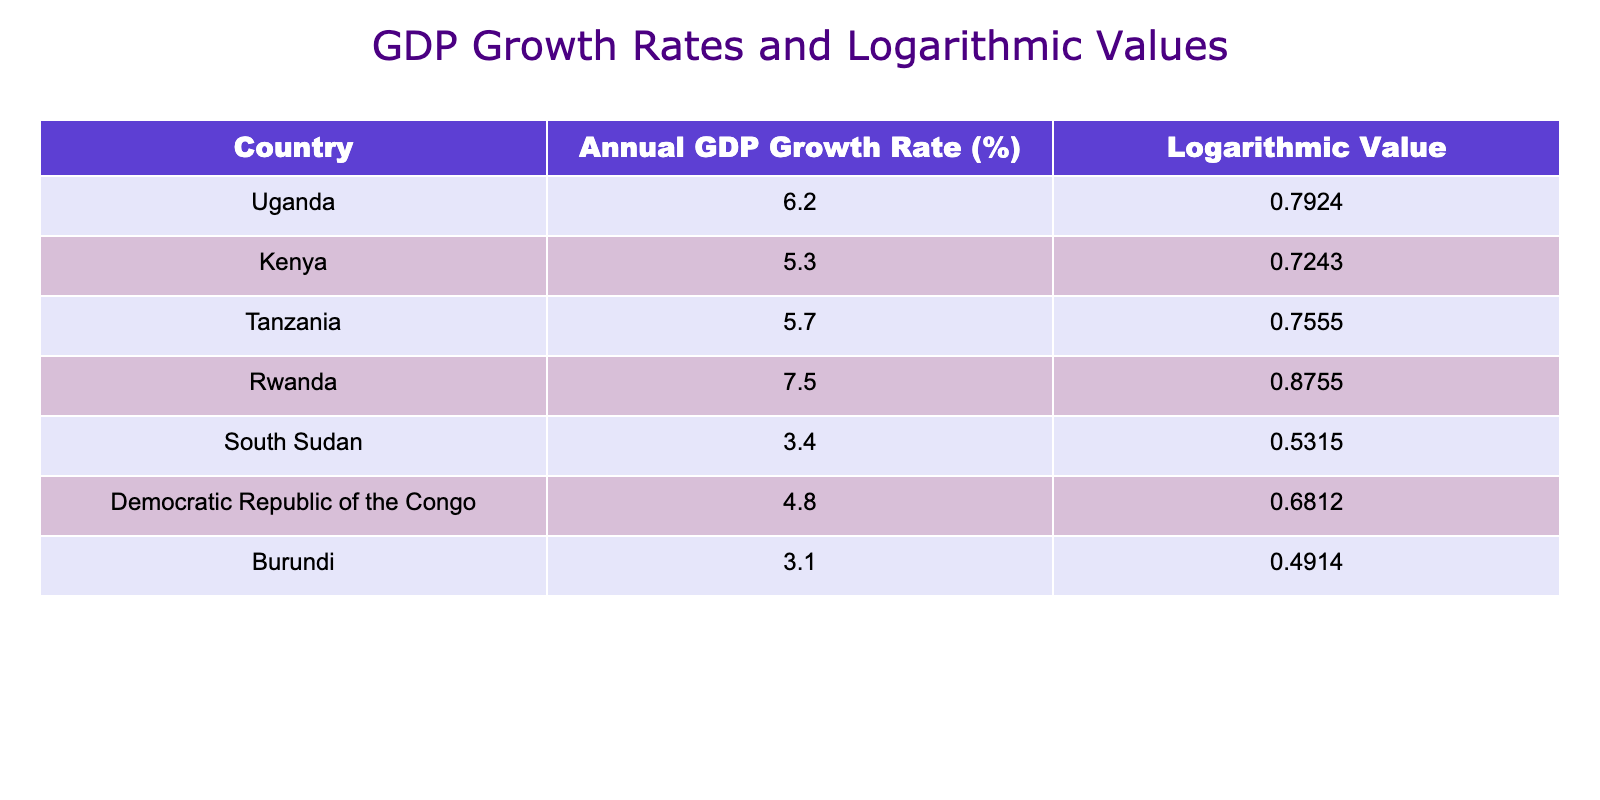What is the annual GDP growth rate of Uganda? Referring to the table, the annual GDP growth rate for Uganda is directly listed under that country.
Answer: 6.2% Which neighboring country has the highest annual GDP growth rate? By comparing the growth rates of the listed neighboring countries, Rwanda has the highest rate at 7.5%.
Answer: Rwanda What is the difference in annual GDP growth rate between Uganda and Kenya? The growth rate of Uganda is 6.2% and that of Kenya is 5.3%. The difference is calculated as 6.2 - 5.3 = 0.9%.
Answer: 0.9% What is the average annual GDP growth rate of all the countries listed? To find the average, we sum the growth rates (6.2 + 5.3 + 5.7 + 7.5 + 3.4 + 4.8 + 3.1) which equals 36.0%. Then we divide by the number of countries (7) to get 36.0 / 7 = 5.14%.
Answer: 5.14% Is the logarithmic value of Uganda's growth rate greater than that of South Sudan? Comparing the logarithmic values, the value for Uganda is 0.7924 and for South Sudan is 0.5315. Since 0.7924 is greater than 0.5315, the statement is true.
Answer: Yes What is the sum of the logarithmic values for Tanzania and the Democratic Republic of the Congo? The logarithmic value for Tanzania is 0.7555 and for the Democratic Republic of the Congo is 0.6812. Adding these two values together gives 0.7555 + 0.6812 = 1.4367.
Answer: 1.4367 Which country has the lowest annual GDP growth rate and what is that rate? From the table, the country with the lowest annual GDP growth rate is Burundi with a growth rate of 3.1%.
Answer: Burundi, 3.1% If the annual GDP growth rates of Uganda and Tanzania were to be combined for a hypothetical project, what would be their total? The combined growth rates for Uganda (6.2%) and Tanzania (5.7%) add up to 6.2 + 5.7 = 11.9%.
Answer: 11.9% Is the annual GDP growth rate of Rwanda more than twice that of South Sudan? Rwanda's growth rate is 7.5% and South Sudan's is 3.4%. Multiplying South Sudan’s rate by 2 gives 2 * 3.4 = 6.8%. Since 7.5% is greater than 6.8%, the statement is true.
Answer: Yes 